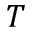<formula> <loc_0><loc_0><loc_500><loc_500>T</formula> 